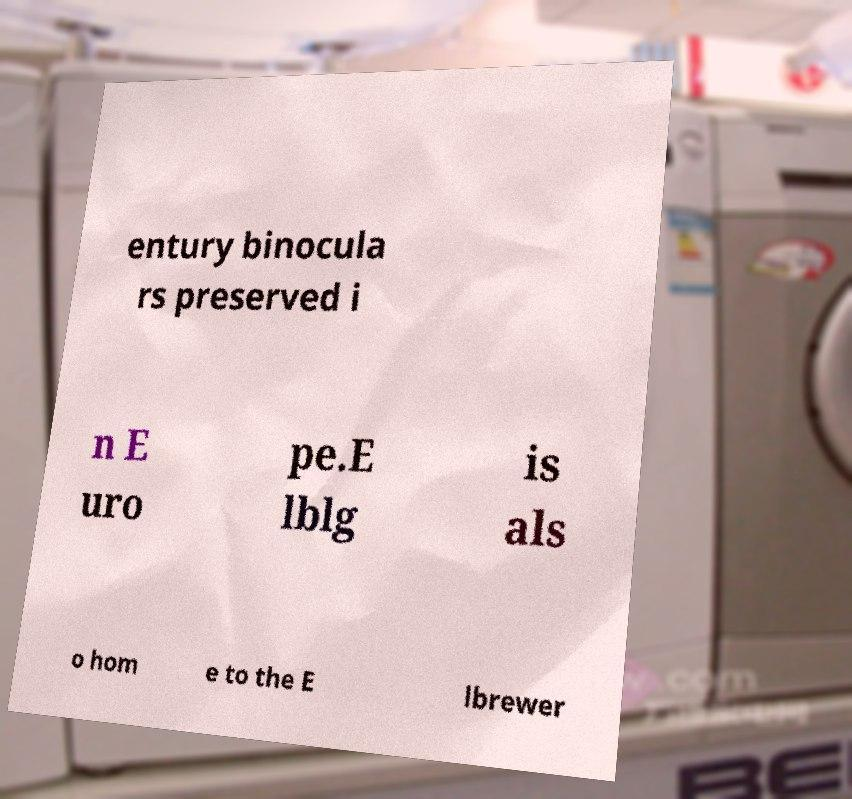Could you assist in decoding the text presented in this image and type it out clearly? entury binocula rs preserved i n E uro pe.E lblg is als o hom e to the E lbrewer 